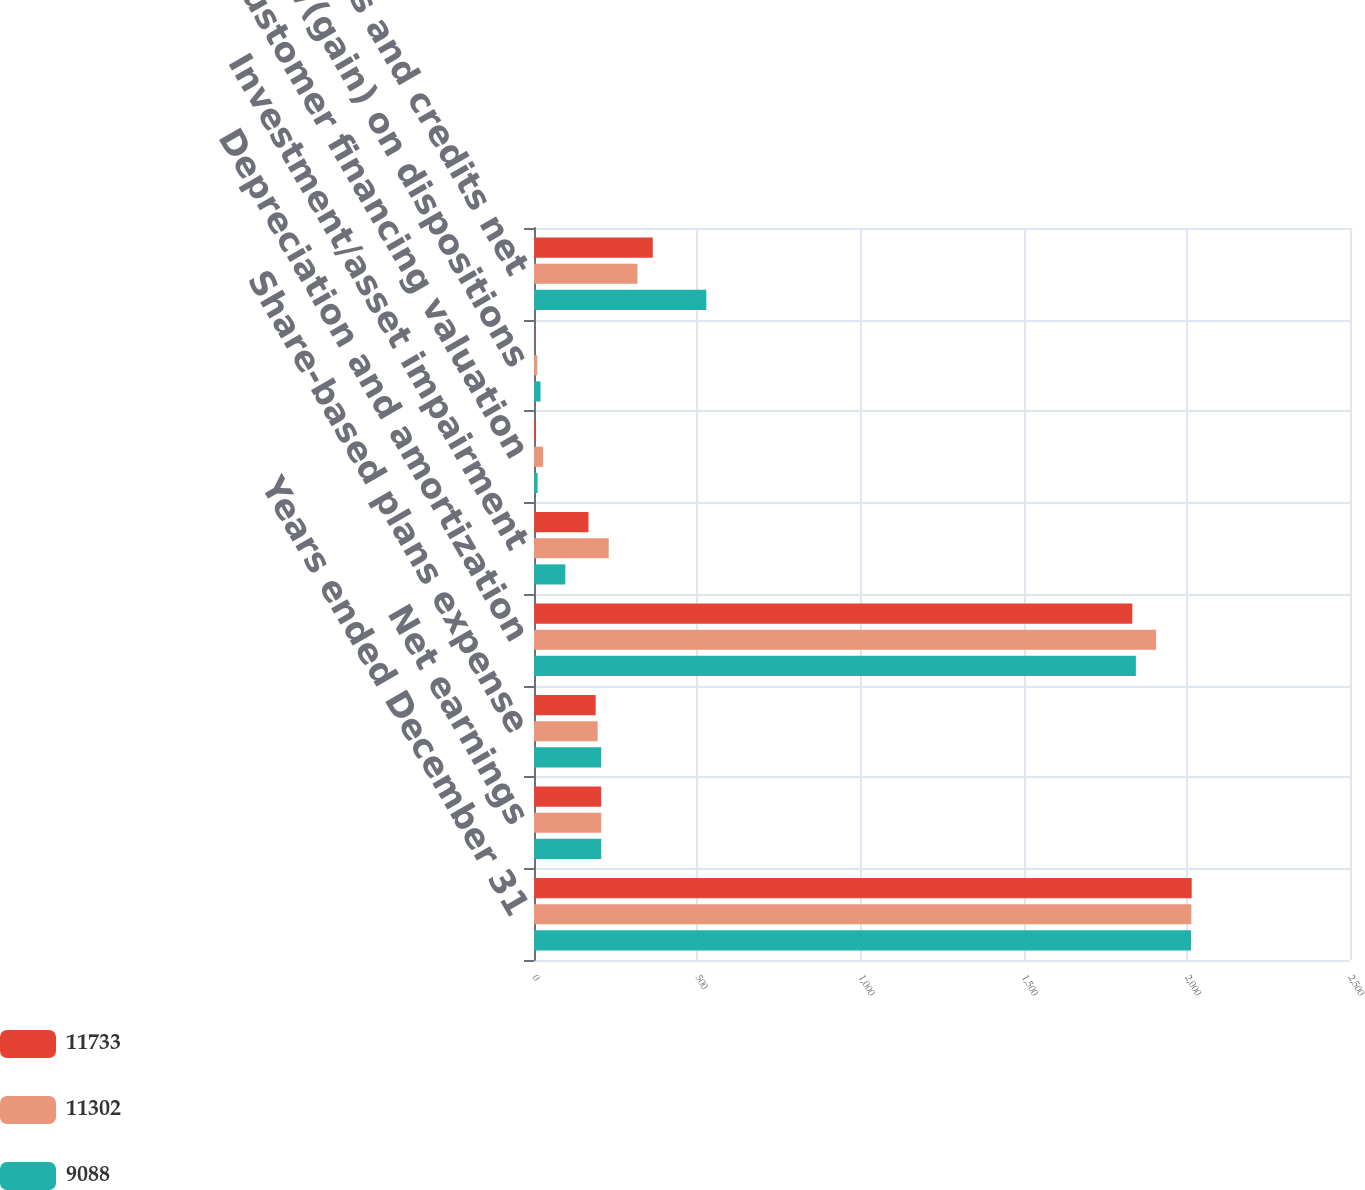Convert chart to OTSL. <chart><loc_0><loc_0><loc_500><loc_500><stacked_bar_chart><ecel><fcel>Years ended December 31<fcel>Net earnings<fcel>Share-based plans expense<fcel>Depreciation and amortization<fcel>Investment/asset impairment<fcel>Customer financing valuation<fcel>Loss/(gain) on dispositions<fcel>Other charges and credits net<nl><fcel>11733<fcel>2015<fcel>206<fcel>189<fcel>1833<fcel>167<fcel>5<fcel>1<fcel>364<nl><fcel>11302<fcel>2014<fcel>206<fcel>195<fcel>1906<fcel>229<fcel>28<fcel>10<fcel>317<nl><fcel>9088<fcel>2013<fcel>206<fcel>206<fcel>1844<fcel>96<fcel>11<fcel>20<fcel>528<nl></chart> 